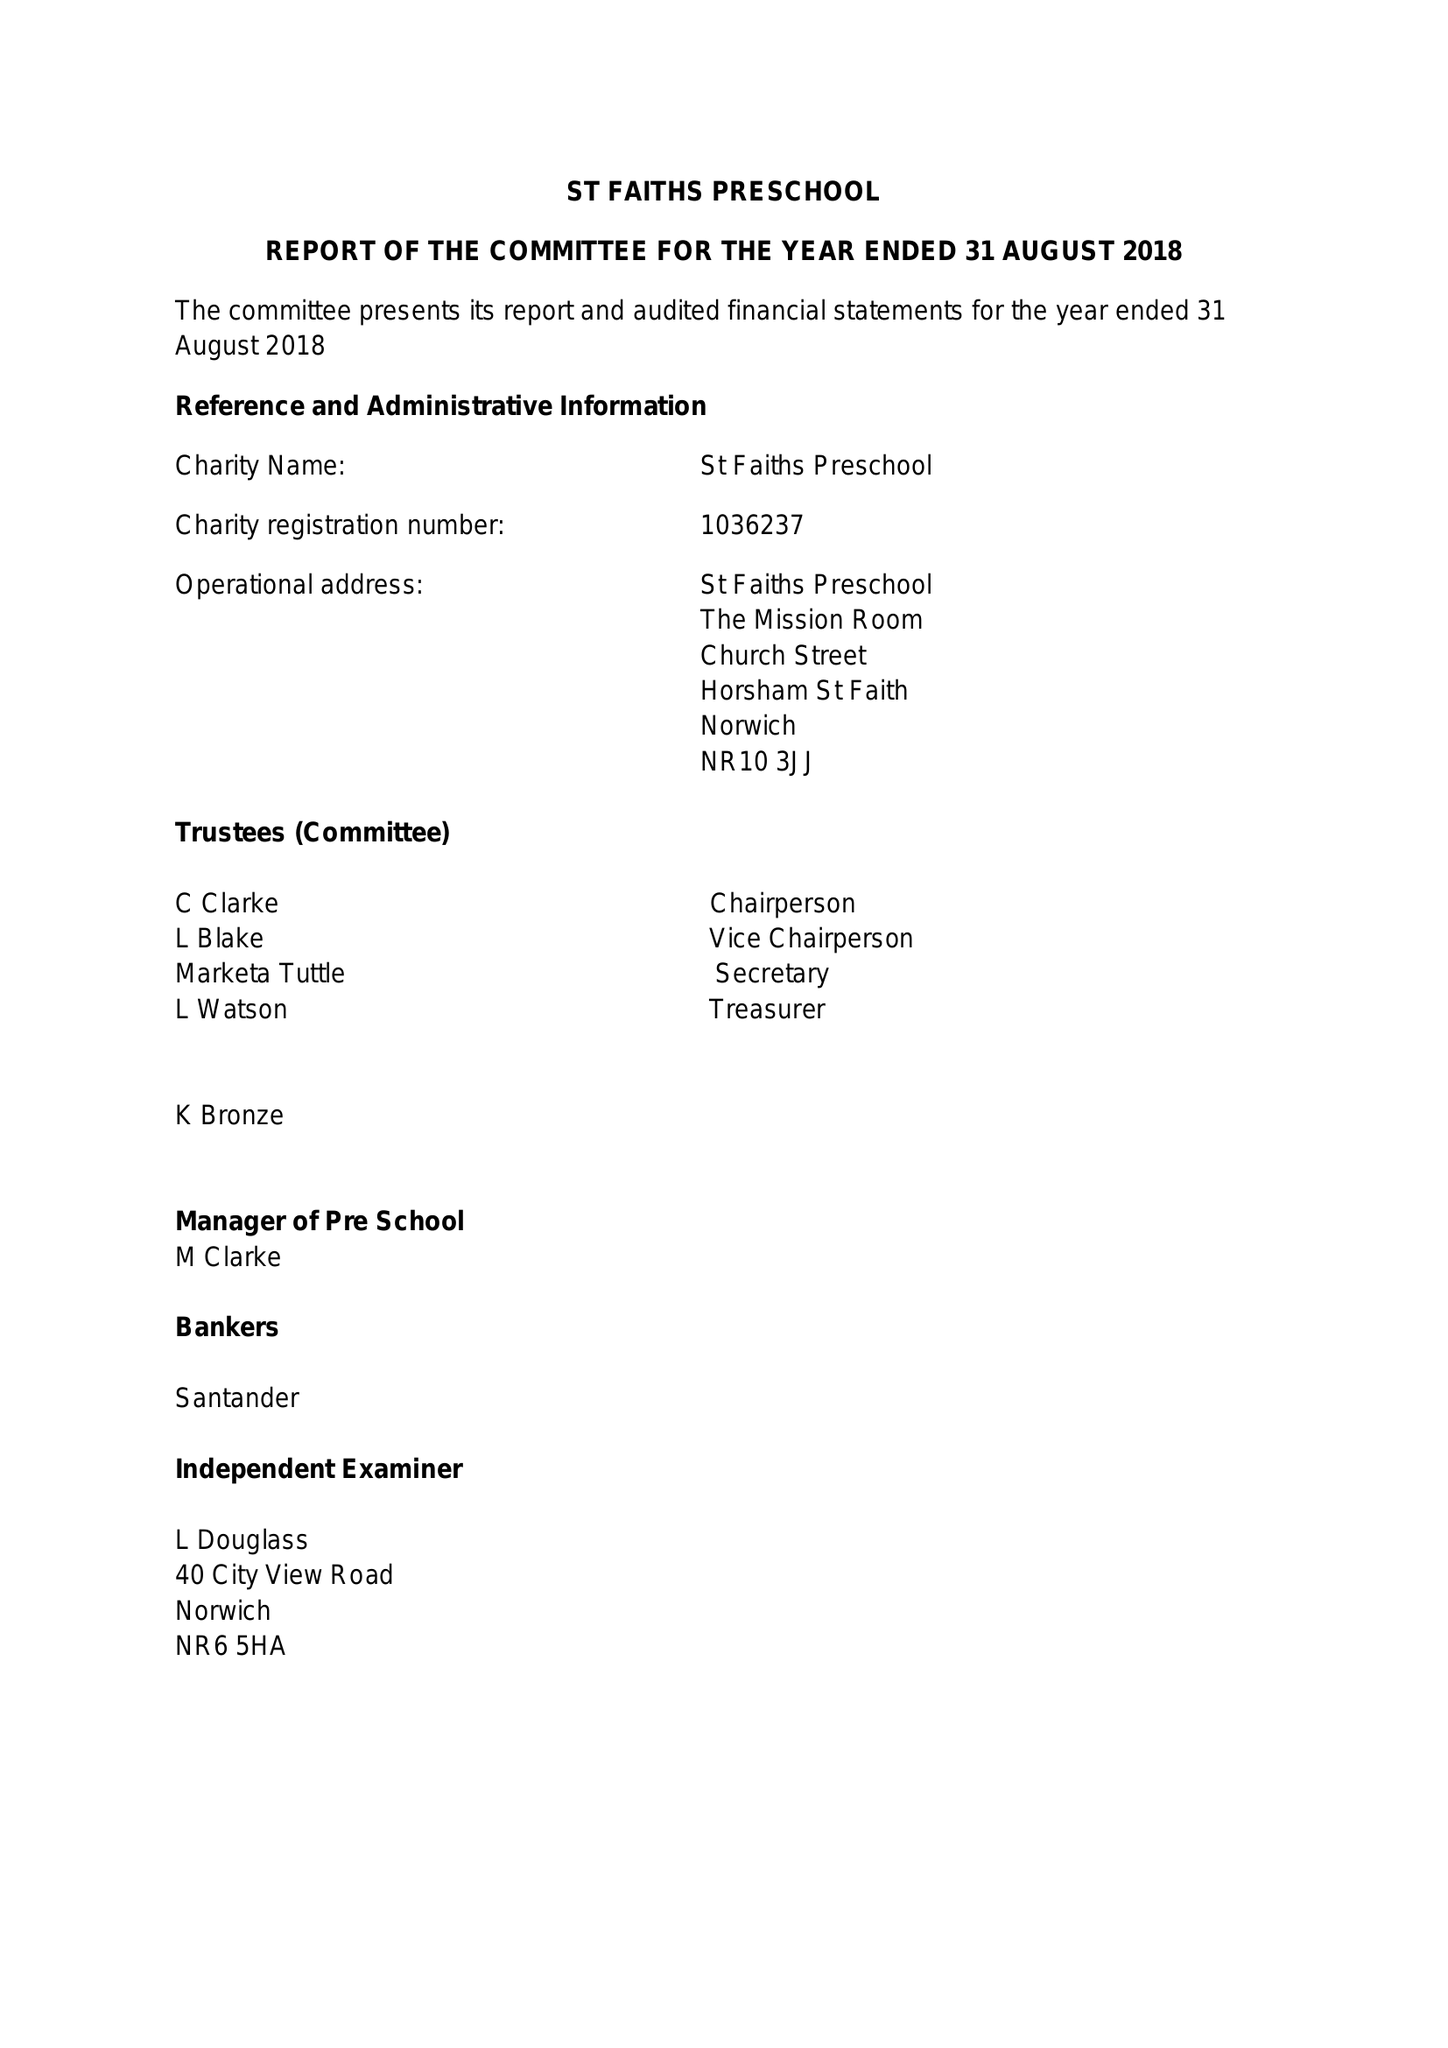What is the value for the address__post_town?
Answer the question using a single word or phrase. NORWICH 